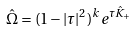<formula> <loc_0><loc_0><loc_500><loc_500>\hat { \Omega } = ( 1 - | \tau | ^ { 2 } ) ^ { k } e ^ { \tau \hat { K } _ { + } }</formula> 